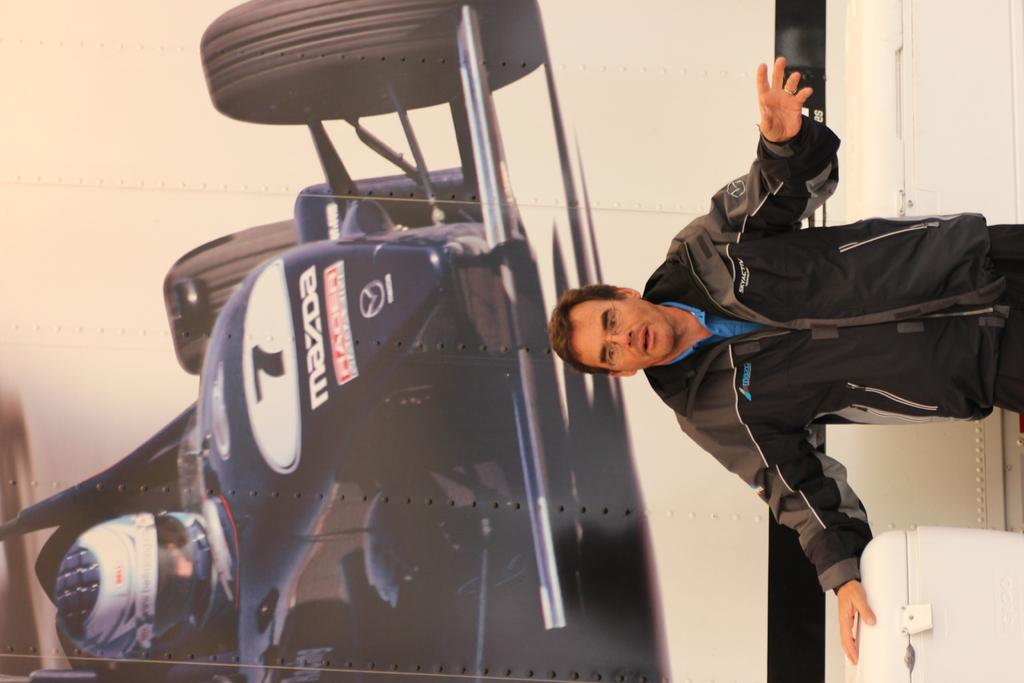<image>
Create a compact narrative representing the image presented. A man stands in front of a larger picture of the #7 Mazda Racer. 